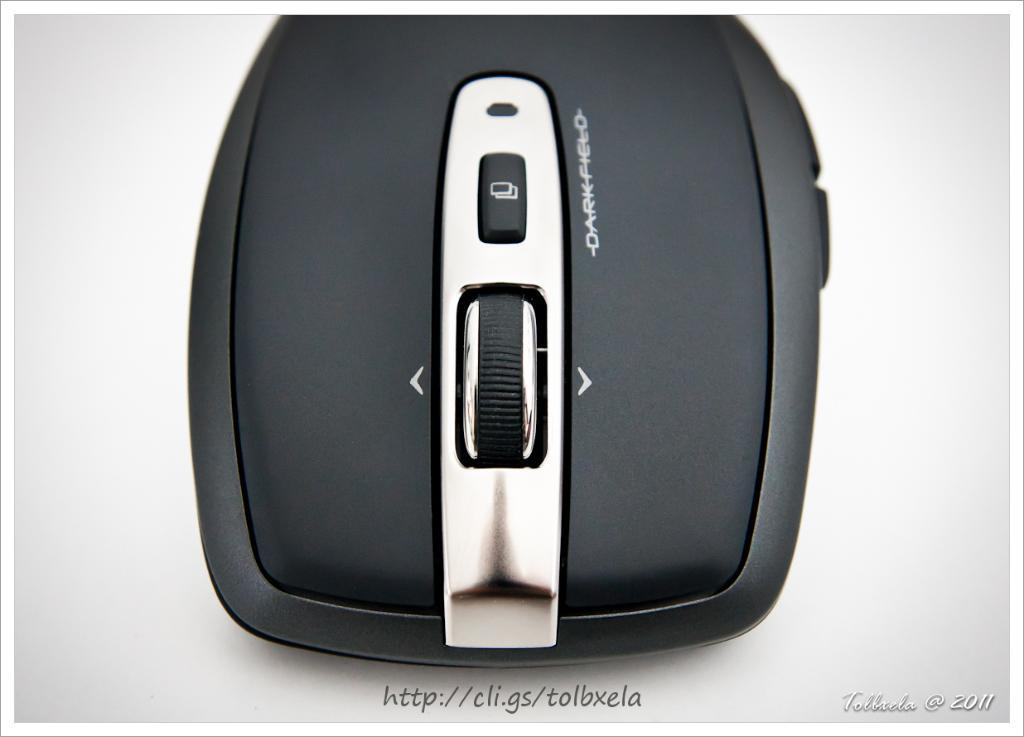What type of animal is present in the image? There is a mouse in the image. Is there any text present on the mouse? Yes, there is text written on the mouse. What type of grass is growing around the mouse in the image? There is no grass present in the image; it features a mouse with text written on it. Can you tell me how much tax the mouse is paying in the image? There is no reference to tax or any financial information in the image. 